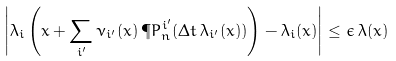Convert formula to latex. <formula><loc_0><loc_0><loc_500><loc_500>\left | \lambda _ { i } \left ( x + \sum _ { i ^ { \prime } } \nu _ { i ^ { \prime } } ( x ) \, \P P ^ { i ^ { \prime } } _ { n } ( \Delta t \, \lambda _ { i ^ { \prime } } ( x ) ) \right ) - \lambda _ { i } ( x ) \right | \leq \epsilon \, \lambda ( x )</formula> 